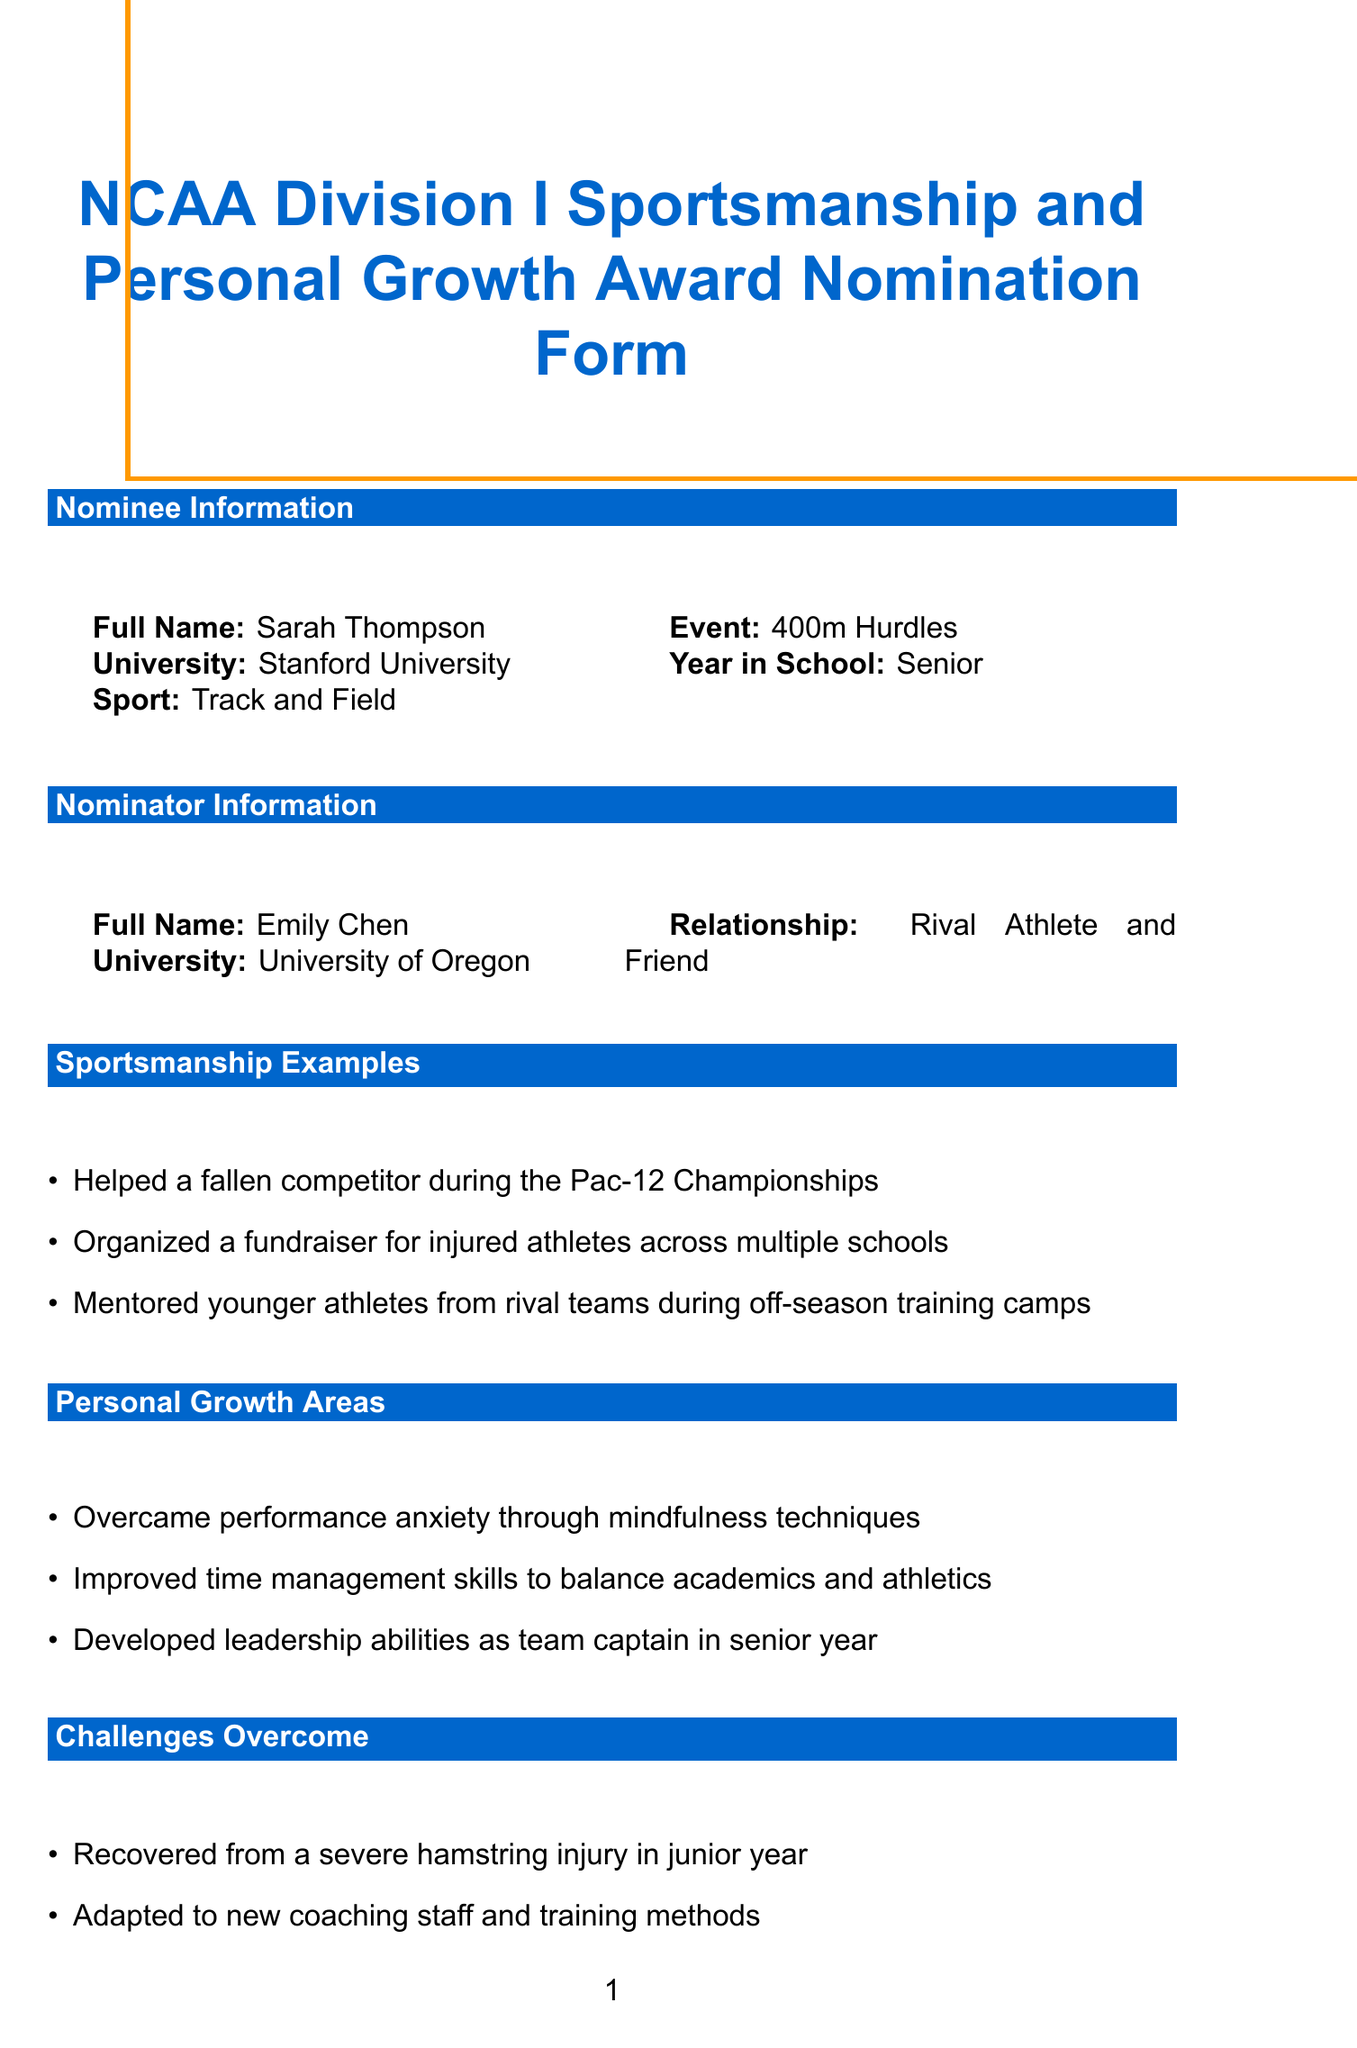What is the nominee's full name? The nominee's full name is provided in the nominee information section of the document.
Answer: Sarah Thompson Which sport does the nominee compete in? The document specifies the sport that the nominee participates in under nominee information.
Answer: Track and Field What year in school is the nominee? The year in school is mentioned in the nominee information section of the document.
Answer: Senior What significant challenge did the nominee overcome in her junior year? The document lists challenges overcome by the nominee, including specific challenges during her junior year.
Answer: Severe hamstring injury Who is the author of the letter of recommendation? The document indicates the author of the letter of recommendation in the relevant section.
Answer: Coach Lisa Martinez What award is the nominee a conference nominee for? The additional awards section includes this specific award that the nominee is recognized for.
Answer: NCAA Woman of the Year Conference Nominee How many semesters was the nominee on the Dean's List? This information is found in the academic achievements section detailing the nominee's academic successes.
Answer: 6 What was one of the nominee's actions to promote mental health awareness? The impact on others section describes actions taken by the nominee regarding mental health awareness.
Answer: Advocated for mental health awareness in college athletics What type of document is the NCAA Division I Sportsmanship and Personal Growth Award Nomination Form? The title of the document specifies its purpose and type clearly.
Answer: Nomination Form 